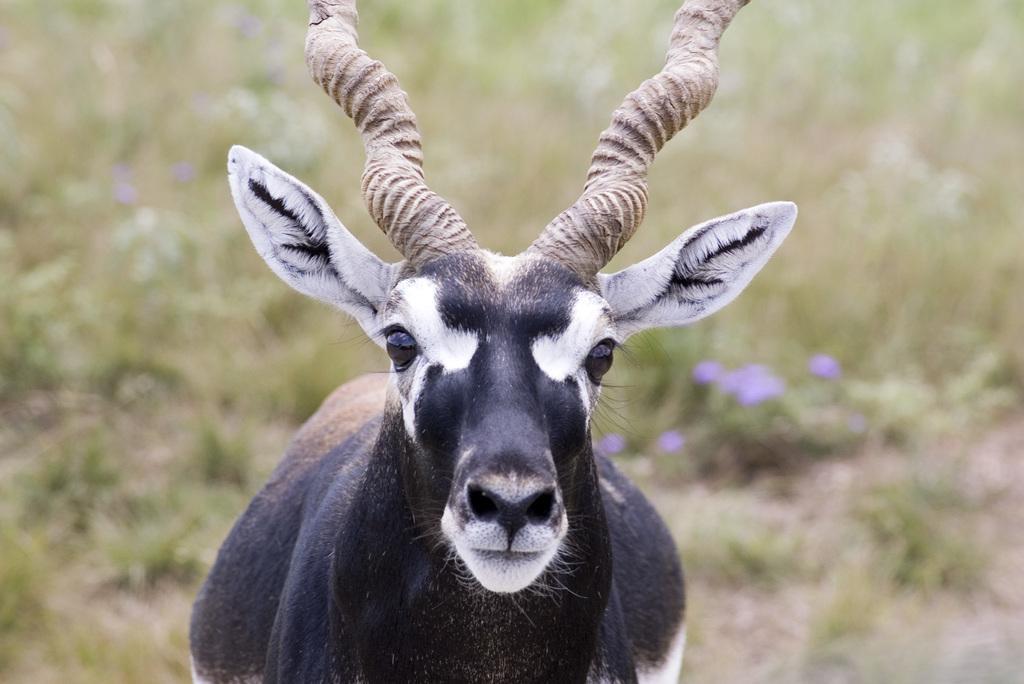Describe this image in one or two sentences. In this image there is an animal. Background there are plants on the land. 